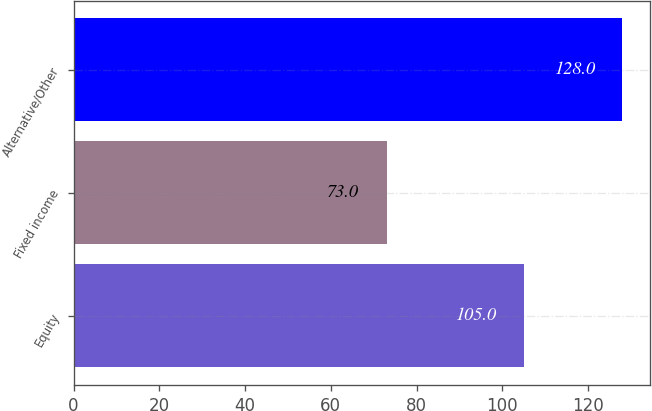Convert chart. <chart><loc_0><loc_0><loc_500><loc_500><bar_chart><fcel>Equity<fcel>Fixed income<fcel>Alternative/Other<nl><fcel>105<fcel>73<fcel>128<nl></chart> 